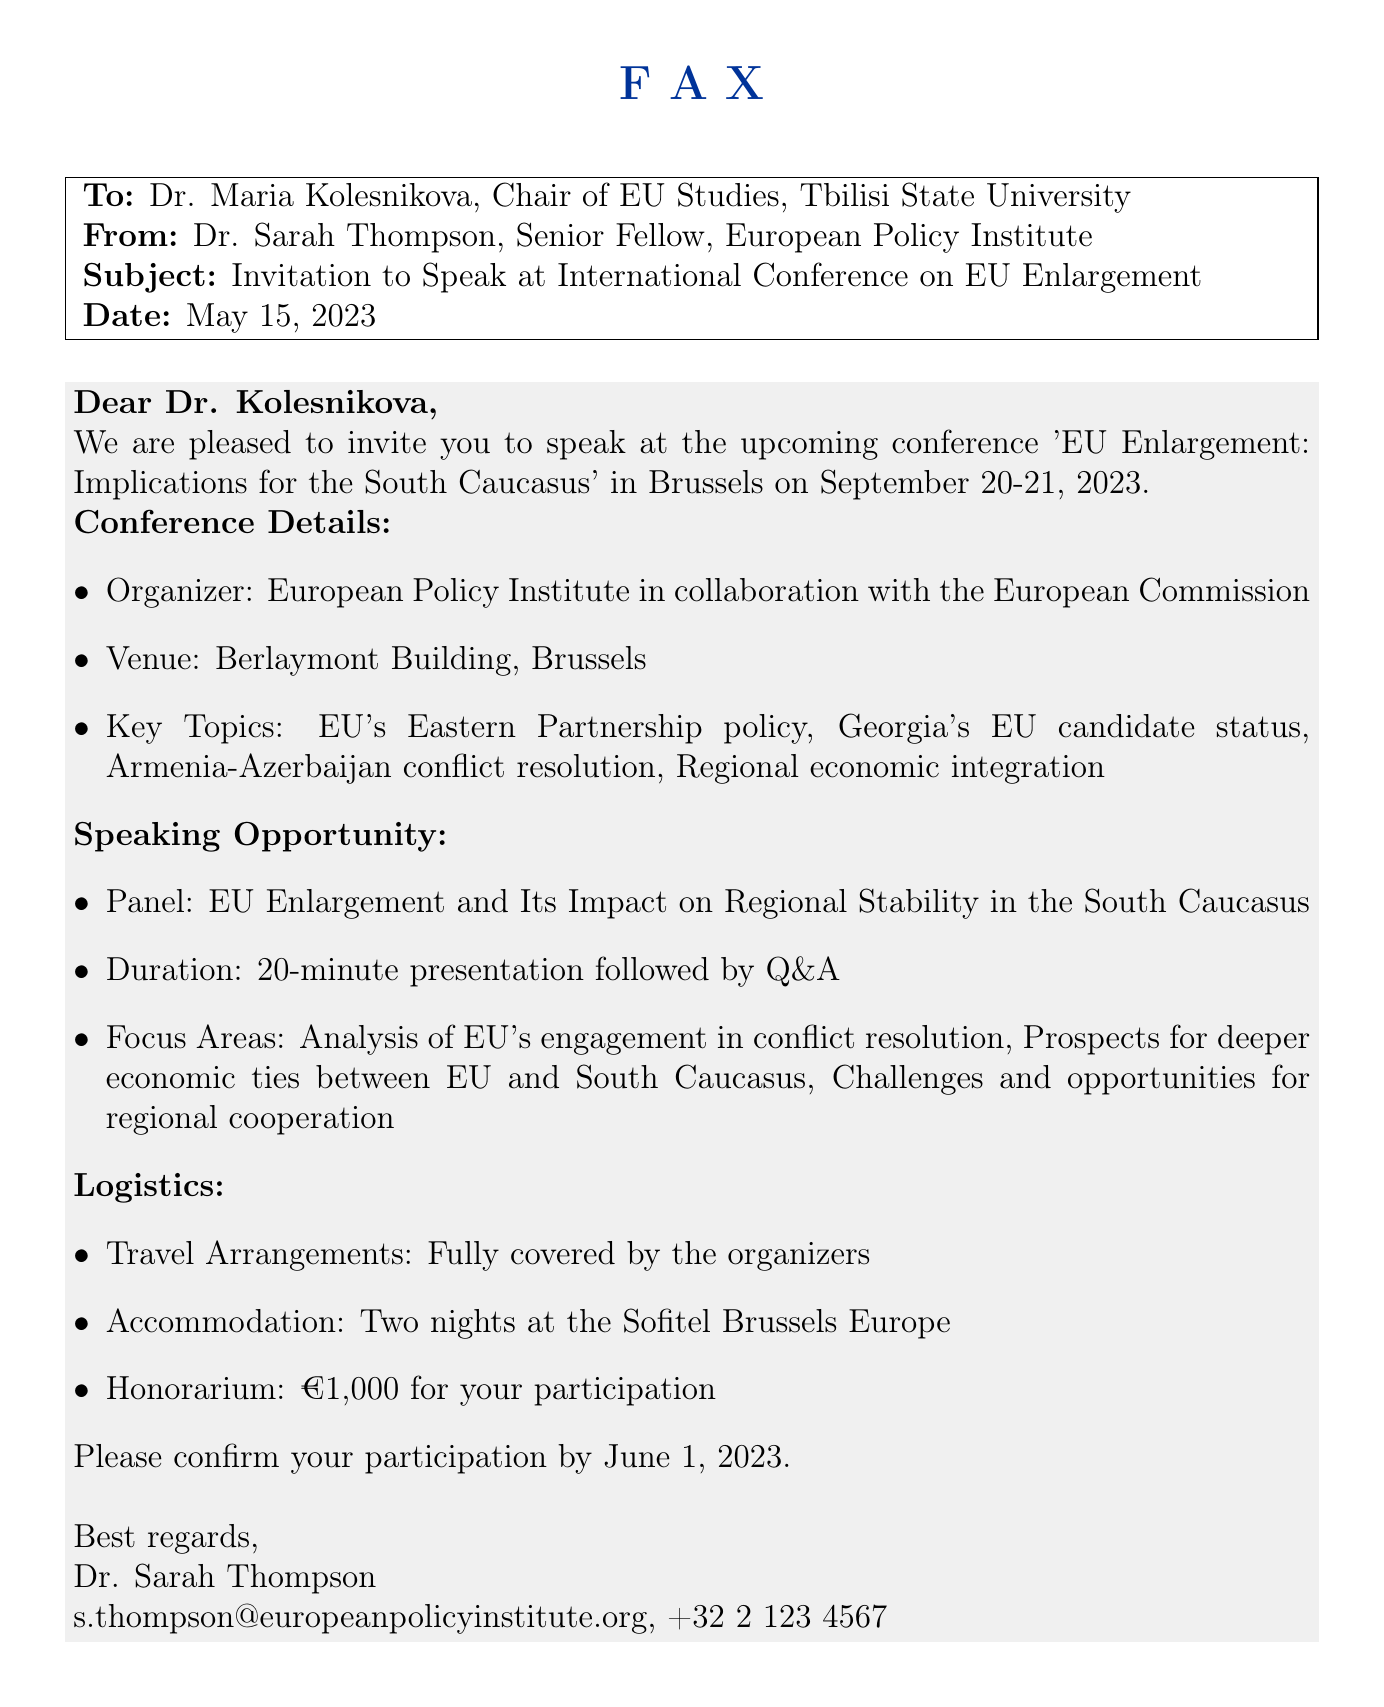What is the name of the chair of EU Studies? The document provides the name of the chair in the "To" section, which is Dr. Maria Kolesnikova.
Answer: Dr. Maria Kolesnikova When is the conference taking place? The date of the conference is mentioned in the opening of the invitation, specifically listing September 20-21, 2023.
Answer: September 20-21, 2023 What is the honorarium offered to the speaker? The honorarium is specifically stated in the "Logistics" section of the fax as €1,000 for participation.
Answer: €1,000 Who is the sender of the fax? The sender's name is noted in the closing lines of the document, identifying her as Dr. Sarah Thompson.
Answer: Dr. Sarah Thompson What are the key topics of the conference? The key topics are listed in the "Conference Details" section, which covers multiple areas including Georgia's EU candidate status.
Answer: EU's Eastern Partnership policy, Georgia's EU candidate status, Armenia-Azerbaijan conflict resolution, Regional economic integration What type of presentation is expected from the invited speaker? The "Speaking Opportunity" section describes a 20-minute presentation followed by Q&A.
Answer: 20-minute presentation followed by Q&A Where will the conference be held? The venue for the conference is specified in the "Conference Details" section as the Berlaymont Building, Brussels.
Answer: Berlaymont Building, Brussels What should the speaker do by June 1, 2023? The document requests confirmation of participation by this date, making it a specific actionable item.
Answer: Confirm participation 